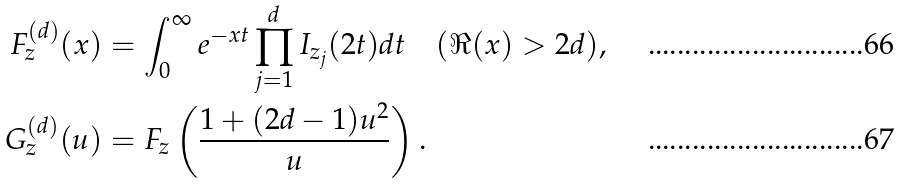<formula> <loc_0><loc_0><loc_500><loc_500>F ^ { ( d ) } _ { z } ( x ) & = \int ^ { \infty } _ { 0 } e ^ { - x t } \prod ^ { d } _ { j = 1 } I _ { z _ { j } } ( 2 t ) d t \quad ( \Re ( x ) > 2 d ) , \\ G ^ { ( d ) } _ { z } ( u ) & = F _ { z } \left ( \frac { 1 + ( 2 d - 1 ) u ^ { 2 } } { u } \right ) .</formula> 